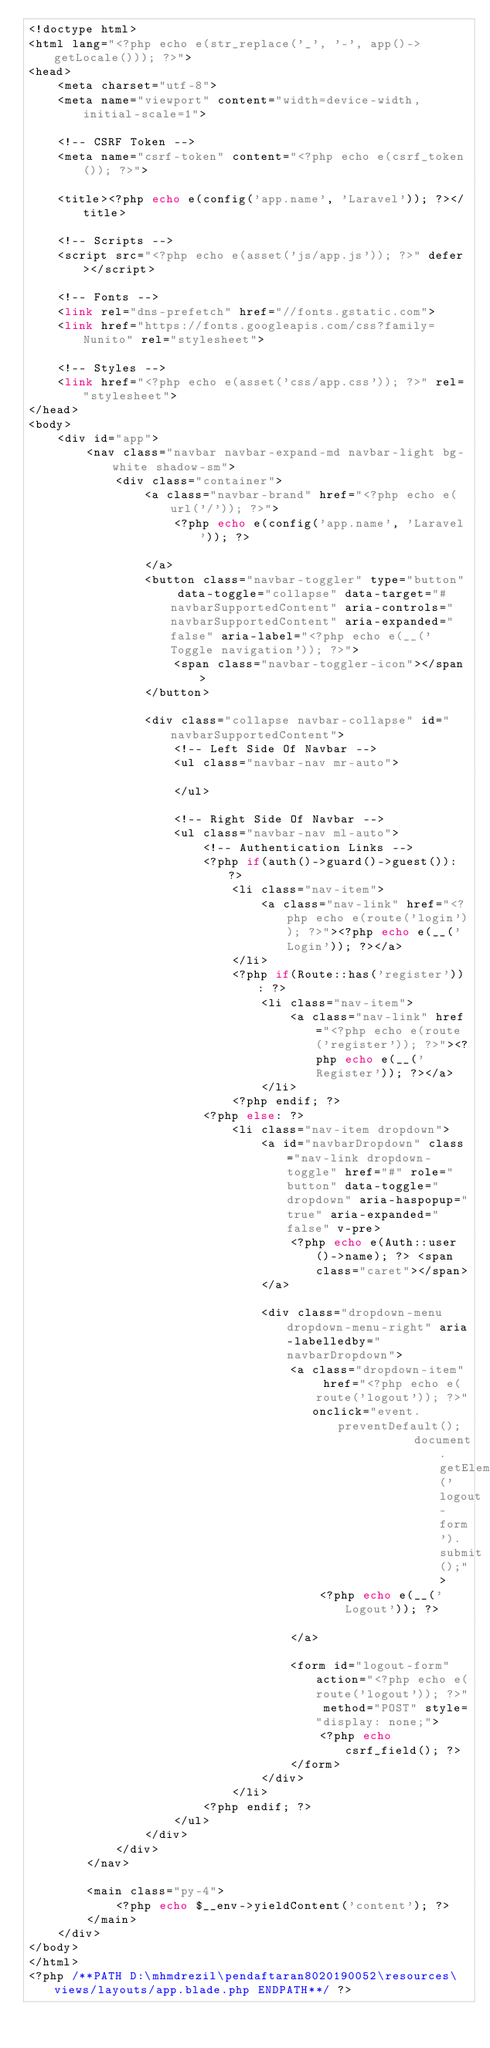<code> <loc_0><loc_0><loc_500><loc_500><_PHP_><!doctype html>
<html lang="<?php echo e(str_replace('_', '-', app()->getLocale())); ?>">
<head>
    <meta charset="utf-8">
    <meta name="viewport" content="width=device-width, initial-scale=1">

    <!-- CSRF Token -->
    <meta name="csrf-token" content="<?php echo e(csrf_token()); ?>">

    <title><?php echo e(config('app.name', 'Laravel')); ?></title>

    <!-- Scripts -->
    <script src="<?php echo e(asset('js/app.js')); ?>" defer></script>

    <!-- Fonts -->
    <link rel="dns-prefetch" href="//fonts.gstatic.com">
    <link href="https://fonts.googleapis.com/css?family=Nunito" rel="stylesheet">

    <!-- Styles -->
    <link href="<?php echo e(asset('css/app.css')); ?>" rel="stylesheet">
</head>
<body>
    <div id="app">
        <nav class="navbar navbar-expand-md navbar-light bg-white shadow-sm">
            <div class="container">
                <a class="navbar-brand" href="<?php echo e(url('/')); ?>">
                    <?php echo e(config('app.name', 'Laravel')); ?>

                </a>
                <button class="navbar-toggler" type="button" data-toggle="collapse" data-target="#navbarSupportedContent" aria-controls="navbarSupportedContent" aria-expanded="false" aria-label="<?php echo e(__('Toggle navigation')); ?>">
                    <span class="navbar-toggler-icon"></span>
                </button>

                <div class="collapse navbar-collapse" id="navbarSupportedContent">
                    <!-- Left Side Of Navbar -->
                    <ul class="navbar-nav mr-auto">

                    </ul>

                    <!-- Right Side Of Navbar -->
                    <ul class="navbar-nav ml-auto">
                        <!-- Authentication Links -->
                        <?php if(auth()->guard()->guest()): ?>
                            <li class="nav-item">
                                <a class="nav-link" href="<?php echo e(route('login')); ?>"><?php echo e(__('Login')); ?></a>
                            </li>
                            <?php if(Route::has('register')): ?>
                                <li class="nav-item">
                                    <a class="nav-link" href="<?php echo e(route('register')); ?>"><?php echo e(__('Register')); ?></a>
                                </li>
                            <?php endif; ?>
                        <?php else: ?>
                            <li class="nav-item dropdown">
                                <a id="navbarDropdown" class="nav-link dropdown-toggle" href="#" role="button" data-toggle="dropdown" aria-haspopup="true" aria-expanded="false" v-pre>
                                    <?php echo e(Auth::user()->name); ?> <span class="caret"></span>
                                </a>

                                <div class="dropdown-menu dropdown-menu-right" aria-labelledby="navbarDropdown">
                                    <a class="dropdown-item" href="<?php echo e(route('logout')); ?>"
                                       onclick="event.preventDefault();
                                                     document.getElementById('logout-form').submit();">
                                        <?php echo e(__('Logout')); ?>

                                    </a>

                                    <form id="logout-form" action="<?php echo e(route('logout')); ?>" method="POST" style="display: none;">
                                        <?php echo csrf_field(); ?>
                                    </form>
                                </div>
                            </li>
                        <?php endif; ?>
                    </ul>
                </div>
            </div>
        </nav>

        <main class="py-4">
            <?php echo $__env->yieldContent('content'); ?>
        </main>
    </div>
</body>
</html>
<?php /**PATH D:\mhmdrezil\pendaftaran8020190052\resources\views/layouts/app.blade.php ENDPATH**/ ?></code> 